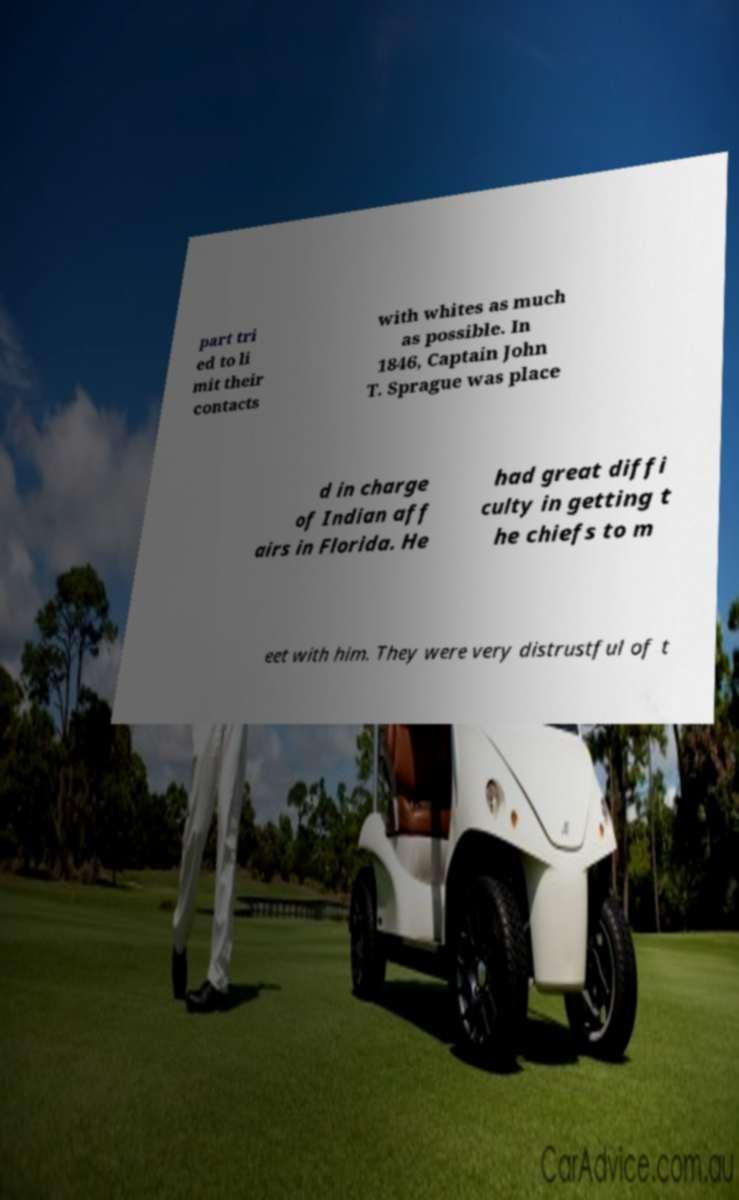Could you assist in decoding the text presented in this image and type it out clearly? part tri ed to li mit their contacts with whites as much as possible. In 1846, Captain John T. Sprague was place d in charge of Indian aff airs in Florida. He had great diffi culty in getting t he chiefs to m eet with him. They were very distrustful of t 